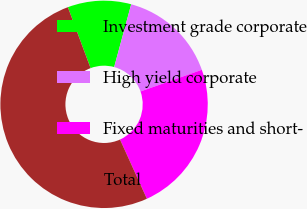Convert chart to OTSL. <chart><loc_0><loc_0><loc_500><loc_500><pie_chart><fcel>Investment grade corporate<fcel>High yield corporate<fcel>Fixed maturities and short-<fcel>Total<nl><fcel>9.89%<fcel>15.38%<fcel>23.63%<fcel>51.1%<nl></chart> 